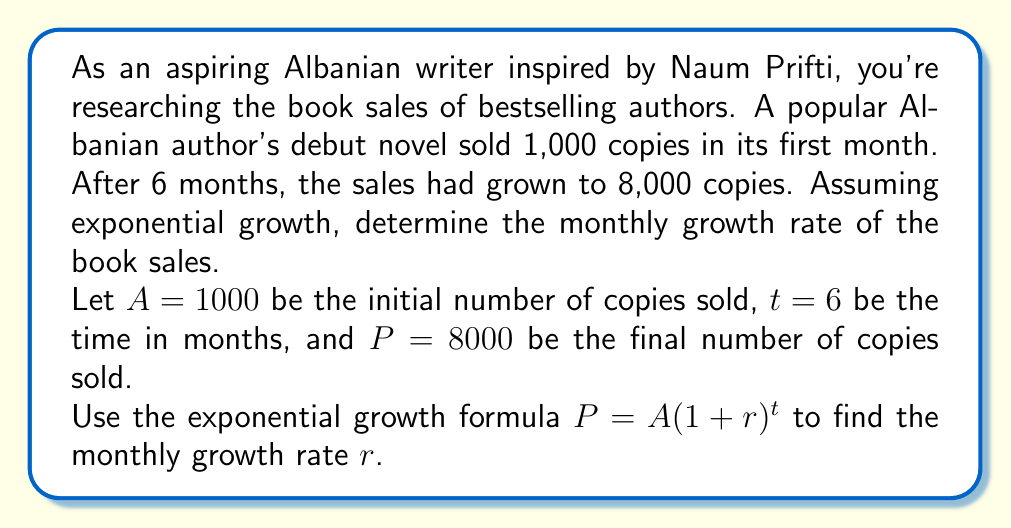Could you help me with this problem? To solve this problem, we'll use the exponential growth formula and follow these steps:

1. Start with the exponential growth formula:
   $$P = A(1+r)^t$$

2. Substitute the known values:
   $$8000 = 1000(1+r)^6$$

3. Divide both sides by 1000:
   $$8 = (1+r)^6$$

4. Take the 6th root of both sides:
   $$\sqrt[6]{8} = 1+r$$

5. Simplify the left side:
   $$8^{\frac{1}{6}} = 1+r$$

6. Subtract 1 from both sides to isolate $r$:
   $$8^{\frac{1}{6}} - 1 = r$$

7. Calculate the value of $r$:
   $$r \approx 1.4142^{\frac{1}{3}} - 1 \approx 0.4142$$

8. Convert to a percentage:
   $$r \approx 0.4142 \times 100\% \approx 41.42\%$$
Answer: The monthly growth rate of the book sales is approximately 41.42%. 